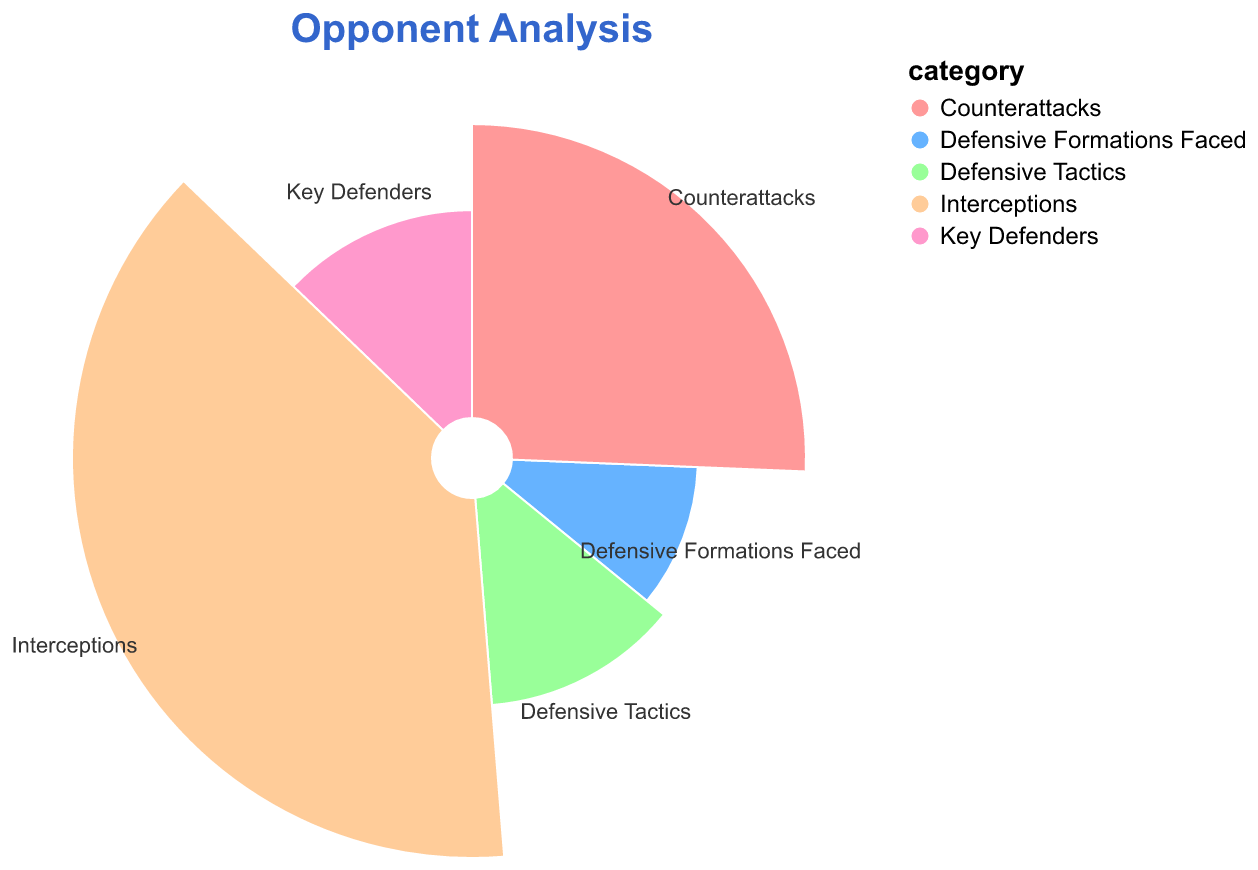What is the title of the polar chart? The title is displayed at the top of the polar chart in larger text.
Answer: Opponent Analysis How many categories are displayed in the polar chart? The polar chart has sections for each category, with the text labeling them directly. Counting the labeled sections gives the total number of categories.
Answer: 5 Which category has the highest value? The category with the most extended section and the largest numerical value corresponds to the highest value; here it is "Interceptions" with a value of 15.
Answer: Interceptions What is the color associated with the "Counterattacks" category? The section labeled "Counterattacks" has a specific color. This color is a shade of pink.
Answer: Pink What is the sum of the values for "Interceptions" and "Counterattacks"? We add the numerical values of the "Interceptions" and "Counterattacks" categories: 15 (Interceptions) + 10 (Counterattacks) = 25.
Answer: 25 Which category has the smallest value? By looking at the shortest section with the smallest value, we can see that "Defensive Formations Faced" has the smallest value of 4.
Answer: Defensive Formations Faced Is the value of "Key Defenders" greater than that of "Defensive Tactics"? "Key Defenders" and "Defensive Tactics" both have the same value, so "Key Defenders" is not greater than "Defensive Tactics". They are equal.
Answer: No What's the difference between the values of "High Press" and "Man-to-Man"? Although "High Press" and "Man-to-Man" aren't directly listed in the chart, we can use the corresponding defensive tactics values (reflected by their associated values) if provided. This question requires more complexity if considered overall.
Answer: N/A (complexity needs proper data alignment) What category has the value of 13? The category corresponding to the numerical value of 13 in the polar chart is displayed as "Mixed Defensive Strategy".
Answer: Mixed Defensive Strategy 